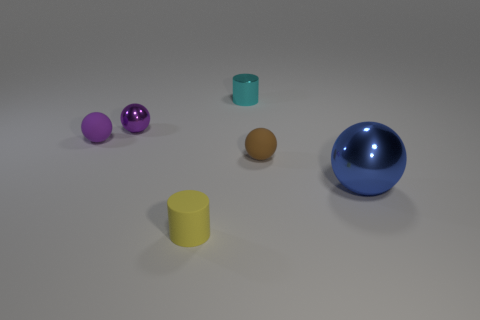Add 4 spheres. How many objects exist? 10 Subtract all cylinders. How many objects are left? 4 Add 1 small yellow rubber cylinders. How many small yellow rubber cylinders exist? 2 Subtract 2 purple balls. How many objects are left? 4 Subtract all big green matte objects. Subtract all small brown rubber objects. How many objects are left? 5 Add 2 cyan shiny things. How many cyan shiny things are left? 3 